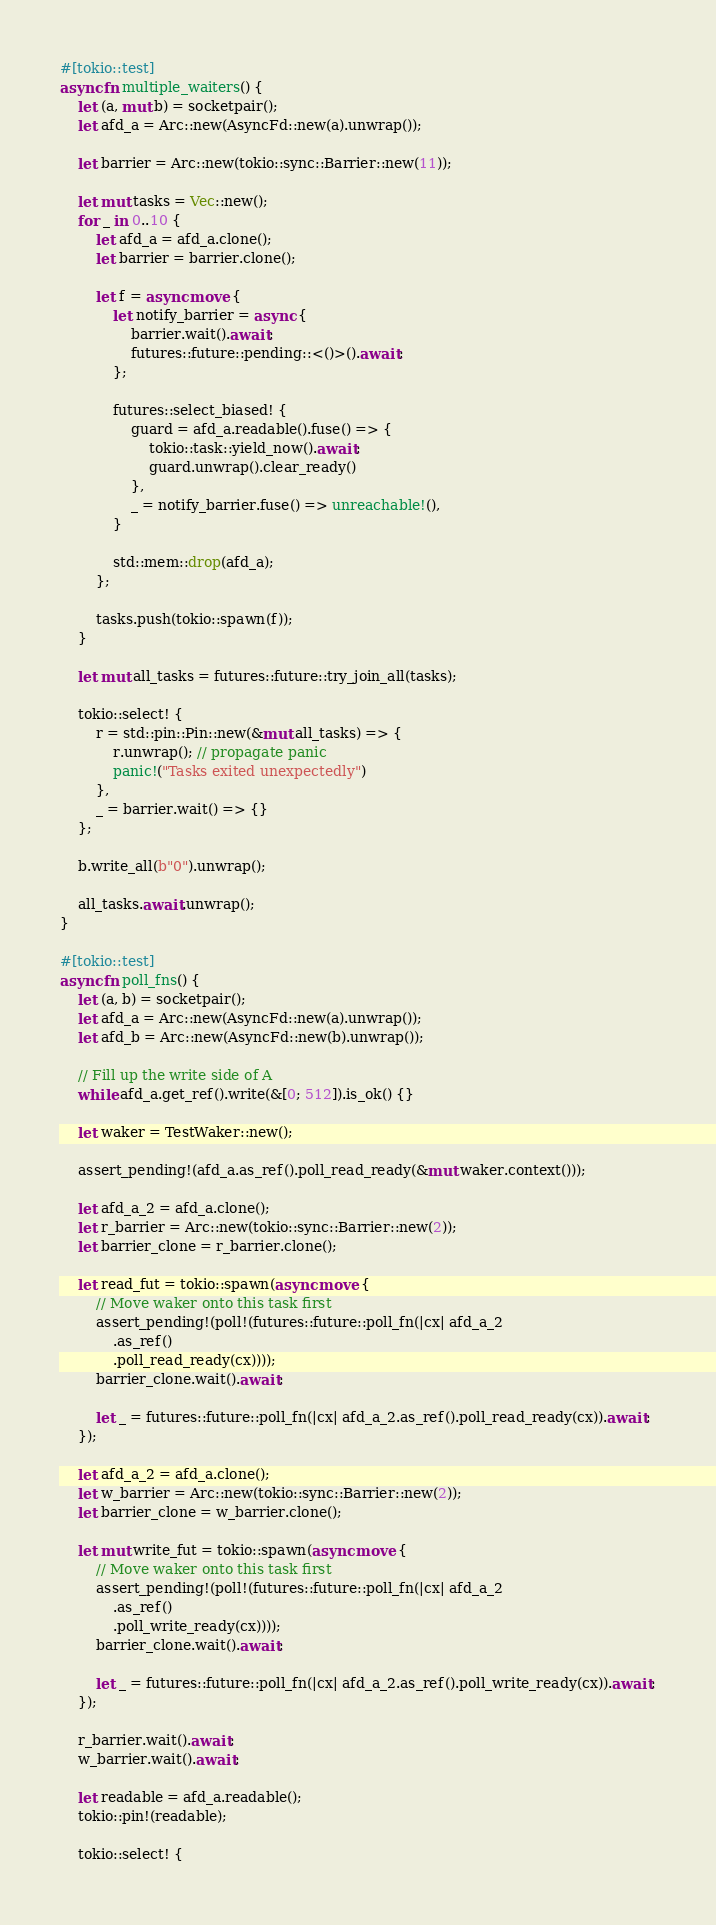Convert code to text. <code><loc_0><loc_0><loc_500><loc_500><_Rust_>#[tokio::test]
async fn multiple_waiters() {
    let (a, mut b) = socketpair();
    let afd_a = Arc::new(AsyncFd::new(a).unwrap());

    let barrier = Arc::new(tokio::sync::Barrier::new(11));

    let mut tasks = Vec::new();
    for _ in 0..10 {
        let afd_a = afd_a.clone();
        let barrier = barrier.clone();

        let f = async move {
            let notify_barrier = async {
                barrier.wait().await;
                futures::future::pending::<()>().await;
            };

            futures::select_biased! {
                guard = afd_a.readable().fuse() => {
                    tokio::task::yield_now().await;
                    guard.unwrap().clear_ready()
                },
                _ = notify_barrier.fuse() => unreachable!(),
            }

            std::mem::drop(afd_a);
        };

        tasks.push(tokio::spawn(f));
    }

    let mut all_tasks = futures::future::try_join_all(tasks);

    tokio::select! {
        r = std::pin::Pin::new(&mut all_tasks) => {
            r.unwrap(); // propagate panic
            panic!("Tasks exited unexpectedly")
        },
        _ = barrier.wait() => {}
    };

    b.write_all(b"0").unwrap();

    all_tasks.await.unwrap();
}

#[tokio::test]
async fn poll_fns() {
    let (a, b) = socketpair();
    let afd_a = Arc::new(AsyncFd::new(a).unwrap());
    let afd_b = Arc::new(AsyncFd::new(b).unwrap());

    // Fill up the write side of A
    while afd_a.get_ref().write(&[0; 512]).is_ok() {}

    let waker = TestWaker::new();

    assert_pending!(afd_a.as_ref().poll_read_ready(&mut waker.context()));

    let afd_a_2 = afd_a.clone();
    let r_barrier = Arc::new(tokio::sync::Barrier::new(2));
    let barrier_clone = r_barrier.clone();

    let read_fut = tokio::spawn(async move {
        // Move waker onto this task first
        assert_pending!(poll!(futures::future::poll_fn(|cx| afd_a_2
            .as_ref()
            .poll_read_ready(cx))));
        barrier_clone.wait().await;

        let _ = futures::future::poll_fn(|cx| afd_a_2.as_ref().poll_read_ready(cx)).await;
    });

    let afd_a_2 = afd_a.clone();
    let w_barrier = Arc::new(tokio::sync::Barrier::new(2));
    let barrier_clone = w_barrier.clone();

    let mut write_fut = tokio::spawn(async move {
        // Move waker onto this task first
        assert_pending!(poll!(futures::future::poll_fn(|cx| afd_a_2
            .as_ref()
            .poll_write_ready(cx))));
        barrier_clone.wait().await;

        let _ = futures::future::poll_fn(|cx| afd_a_2.as_ref().poll_write_ready(cx)).await;
    });

    r_barrier.wait().await;
    w_barrier.wait().await;

    let readable = afd_a.readable();
    tokio::pin!(readable);

    tokio::select! {</code> 